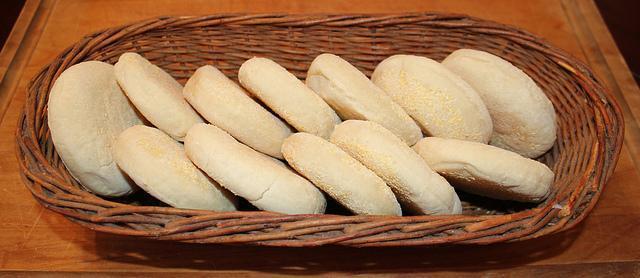How many buns are in the basket?
Give a very brief answer. 12. 